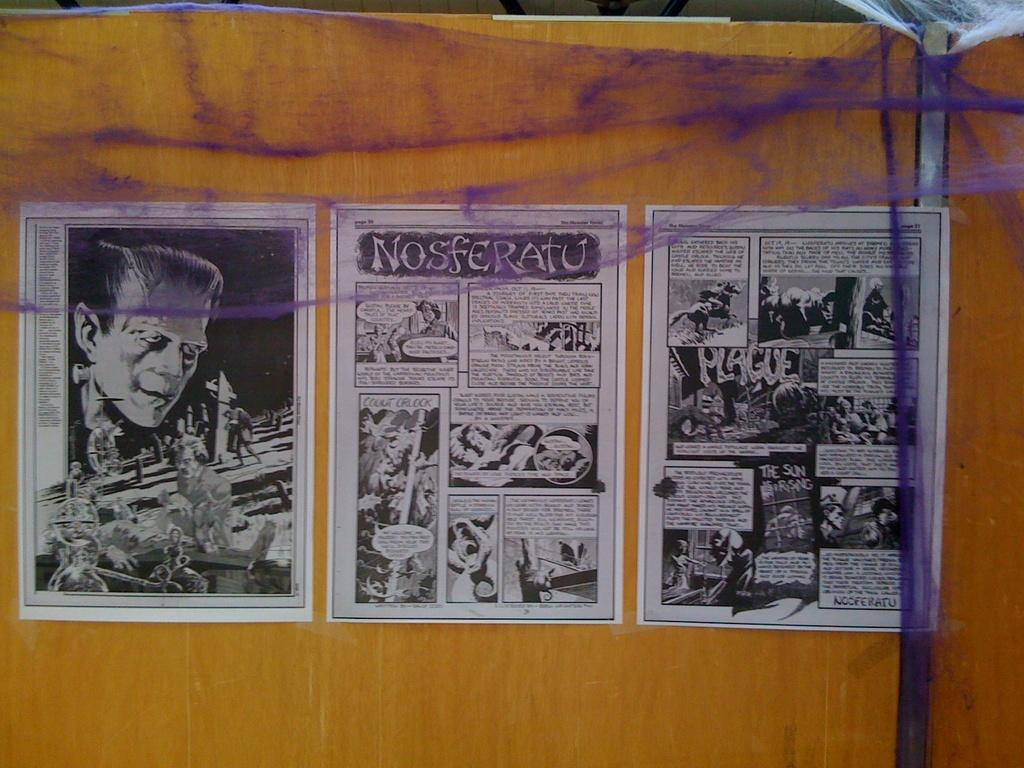<image>
Provide a brief description of the given image. Horror comics including Nosferatu in the middle of the three pages. 